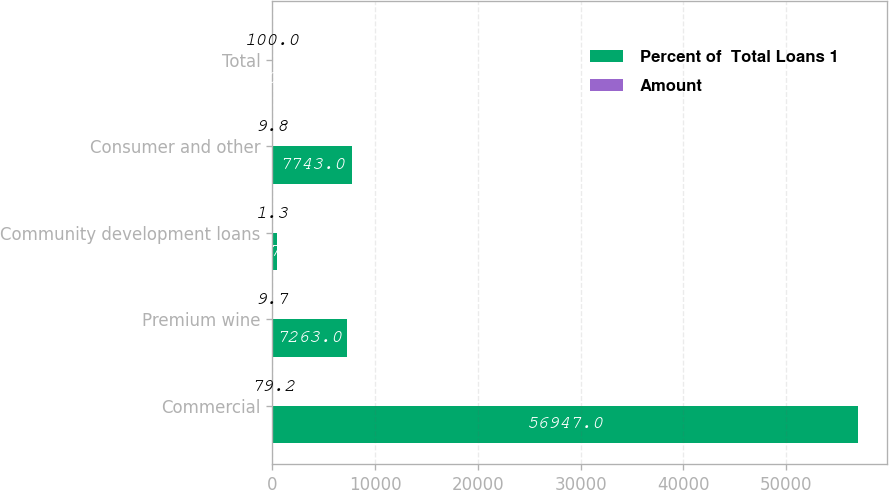Convert chart. <chart><loc_0><loc_0><loc_500><loc_500><stacked_bar_chart><ecel><fcel>Commercial<fcel>Premium wine<fcel>Community development loans<fcel>Consumer and other<fcel>Total<nl><fcel>Percent of  Total Loans 1<fcel>56947<fcel>7263<fcel>497<fcel>7743<fcel>100<nl><fcel>Amount<fcel>79.2<fcel>9.7<fcel>1.3<fcel>9.8<fcel>100<nl></chart> 